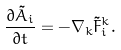Convert formula to latex. <formula><loc_0><loc_0><loc_500><loc_500>\frac { \partial \tilde { A } _ { i } } { \partial t } = - \nabla _ { k } \tilde { F } _ { i } ^ { k } .</formula> 